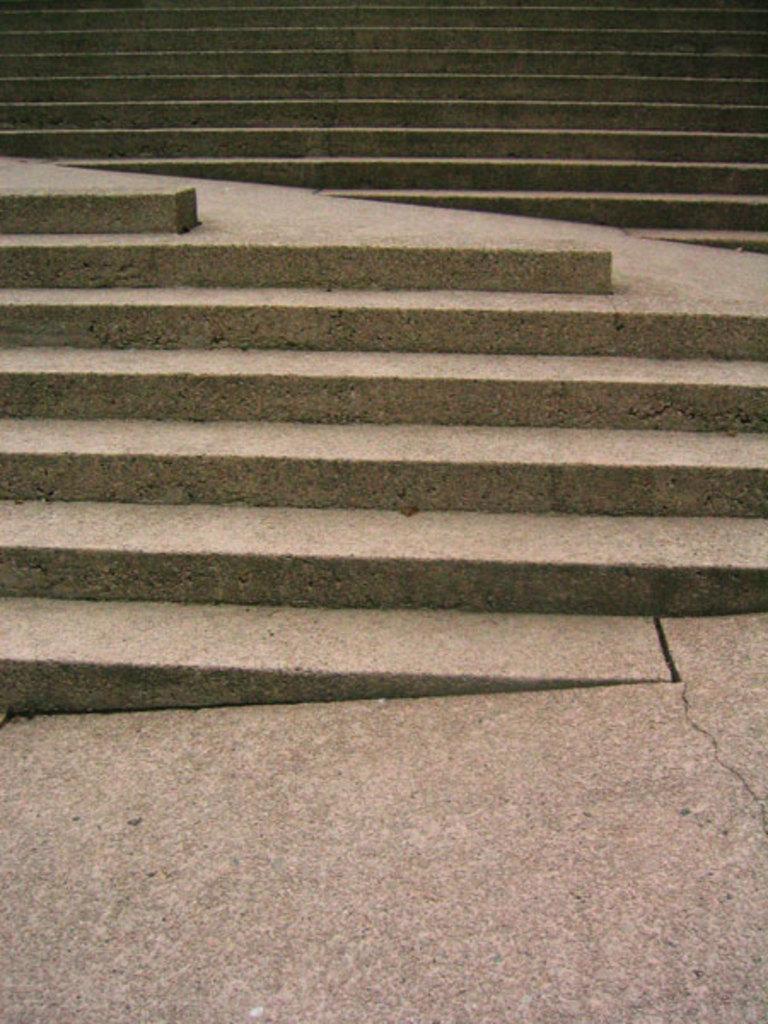Can you describe this image briefly? In this image we can see staircase. At the bottom of the image there is stone surface. 